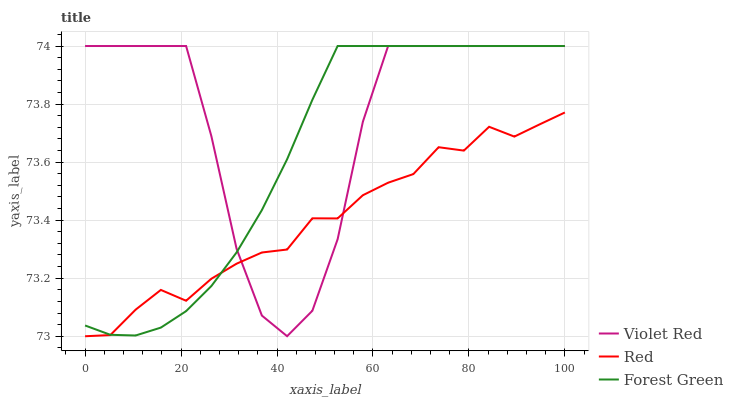Does Red have the minimum area under the curve?
Answer yes or no. Yes. Does Violet Red have the maximum area under the curve?
Answer yes or no. Yes. Does Forest Green have the minimum area under the curve?
Answer yes or no. No. Does Forest Green have the maximum area under the curve?
Answer yes or no. No. Is Forest Green the smoothest?
Answer yes or no. Yes. Is Violet Red the roughest?
Answer yes or no. Yes. Is Red the smoothest?
Answer yes or no. No. Is Red the roughest?
Answer yes or no. No. Does Red have the lowest value?
Answer yes or no. Yes. Does Forest Green have the lowest value?
Answer yes or no. No. Does Forest Green have the highest value?
Answer yes or no. Yes. Does Red have the highest value?
Answer yes or no. No. Does Violet Red intersect Red?
Answer yes or no. Yes. Is Violet Red less than Red?
Answer yes or no. No. Is Violet Red greater than Red?
Answer yes or no. No. 